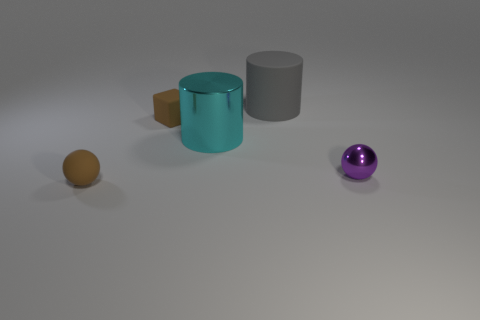Does the tiny brown ball have the same material as the large thing to the left of the gray cylinder?
Offer a terse response. No. What size is the sphere that is the same color as the rubber block?
Your answer should be very brief. Small. Is there a block that has the same material as the tiny purple object?
Your answer should be very brief. No. What number of things are things that are behind the matte cube or tiny brown spheres that are to the left of the gray cylinder?
Offer a very short reply. 2. Is the shape of the purple object the same as the tiny thing that is in front of the purple thing?
Your response must be concise. Yes. How many other things are the same shape as the big metallic object?
Offer a very short reply. 1. How many things are tiny metallic blocks or large cyan metallic objects?
Ensure brevity in your answer.  1. Does the cube have the same color as the small matte sphere?
Provide a short and direct response. Yes. There is a brown matte thing that is in front of the cylinder that is in front of the big gray rubber thing; what shape is it?
Your answer should be compact. Sphere. Is the number of big brown metal cylinders less than the number of tiny rubber spheres?
Offer a terse response. Yes. 